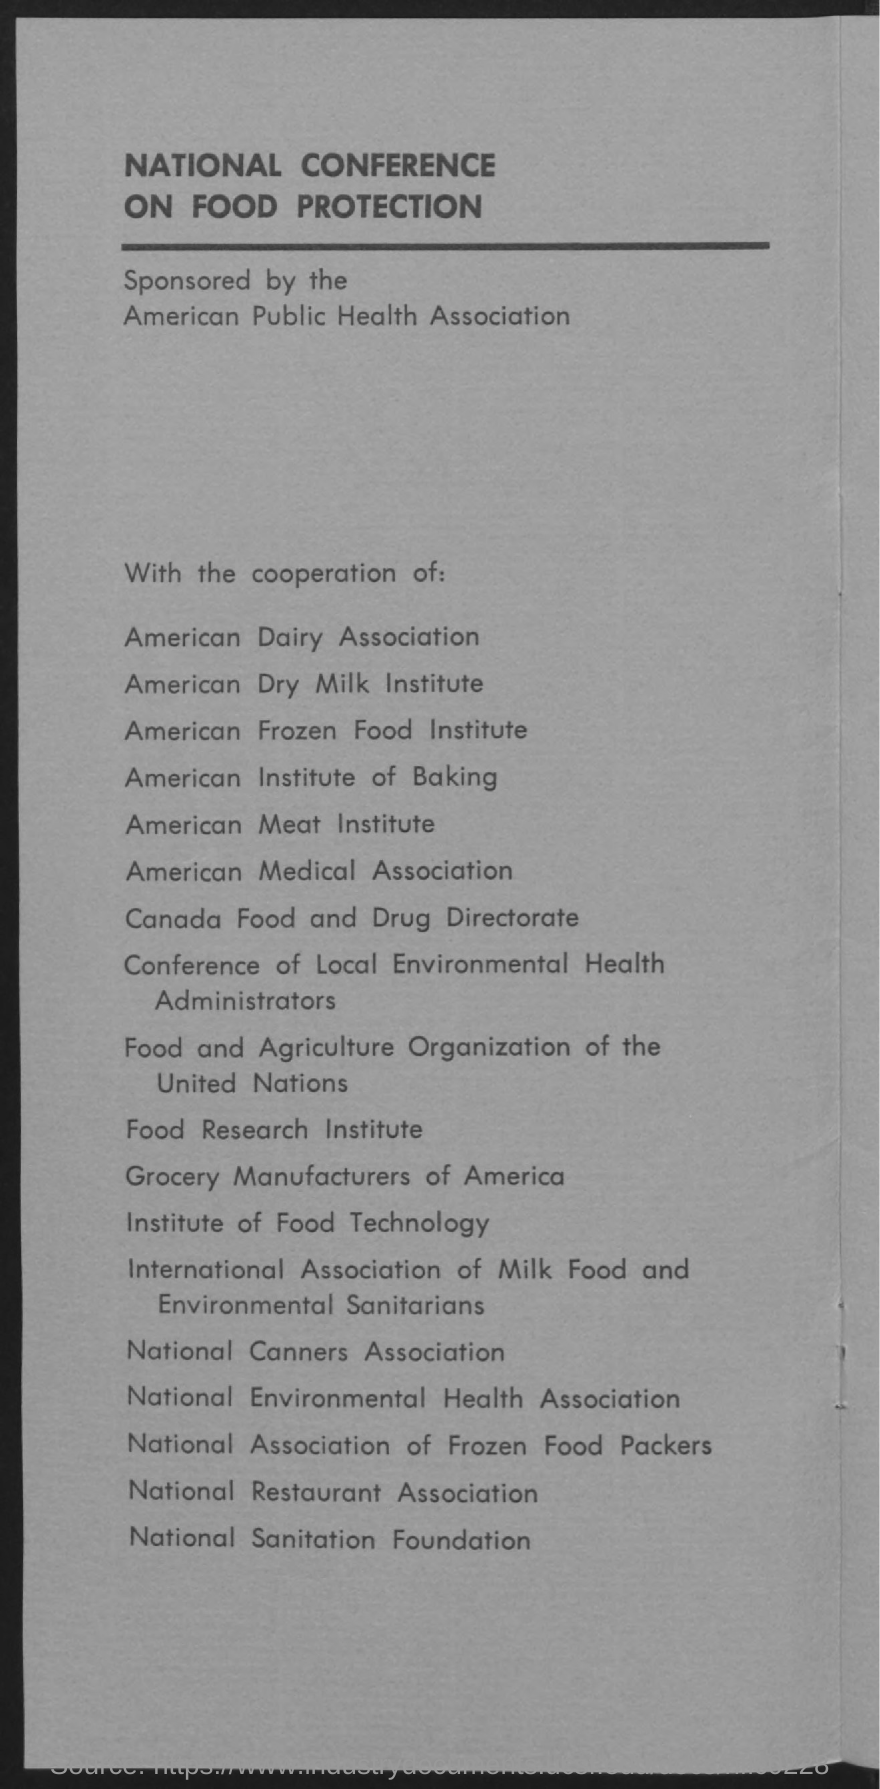Specify some key components in this picture. The National Conference on Food Protection is a gathering of experts and professionals focused on advancing knowledge and practices related to food safety and protection. The National Conference on Food Protection is being sponsored by the American Public Health Association. 